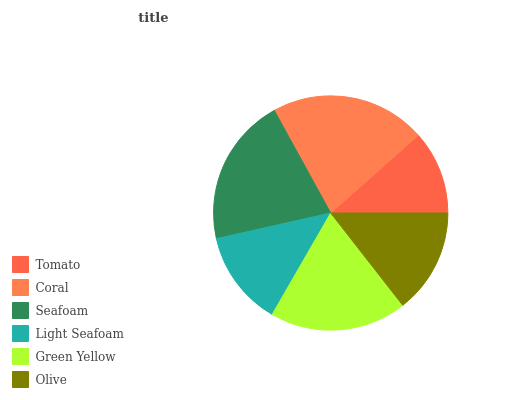Is Tomato the minimum?
Answer yes or no. Yes. Is Coral the maximum?
Answer yes or no. Yes. Is Seafoam the minimum?
Answer yes or no. No. Is Seafoam the maximum?
Answer yes or no. No. Is Coral greater than Seafoam?
Answer yes or no. Yes. Is Seafoam less than Coral?
Answer yes or no. Yes. Is Seafoam greater than Coral?
Answer yes or no. No. Is Coral less than Seafoam?
Answer yes or no. No. Is Green Yellow the high median?
Answer yes or no. Yes. Is Olive the low median?
Answer yes or no. Yes. Is Light Seafoam the high median?
Answer yes or no. No. Is Tomato the low median?
Answer yes or no. No. 